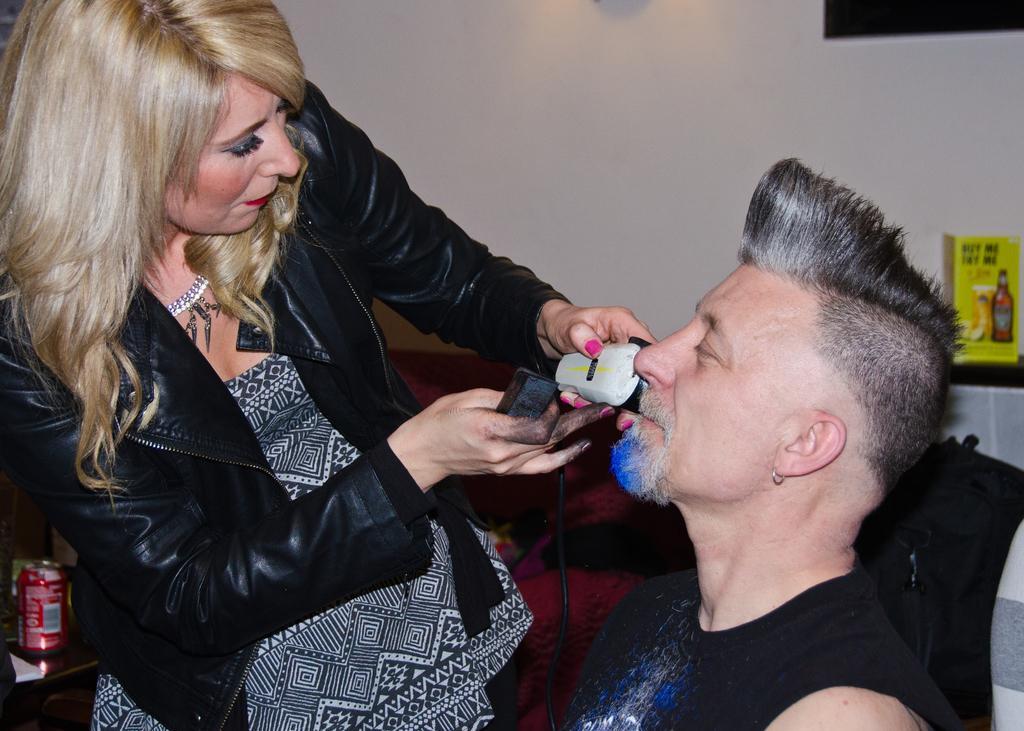Could you give a brief overview of what you see in this image? In this image I see a woman who is wearing black jacket and I see that she is wearing white and black dress and I see that she is holding things in her hands and I see a man over here who is wearing black tank top and I see a can over here. In the background I see the wall and I see the yellow color thing over here. 